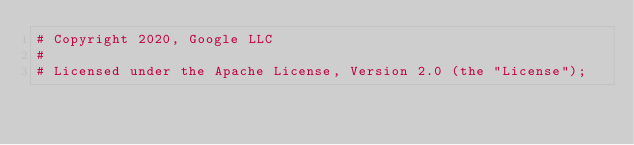<code> <loc_0><loc_0><loc_500><loc_500><_Perl_># Copyright 2020, Google LLC
#
# Licensed under the Apache License, Version 2.0 (the "License");</code> 